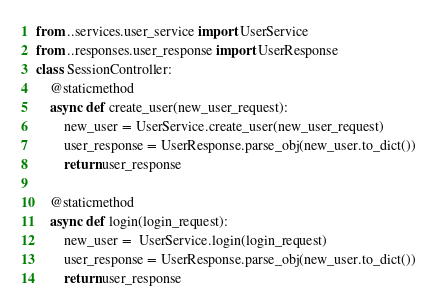Convert code to text. <code><loc_0><loc_0><loc_500><loc_500><_Python_>from ..services.user_service import UserService
from ..responses.user_response import UserResponse
class SessionController:
    @staticmethod
    async def create_user(new_user_request):
        new_user = UserService.create_user(new_user_request)
        user_response = UserResponse.parse_obj(new_user.to_dict())
        return user_response
    
    @staticmethod
    async def login(login_request):
        new_user =  UserService.login(login_request)
        user_response = UserResponse.parse_obj(new_user.to_dict())
        return user_response
</code> 